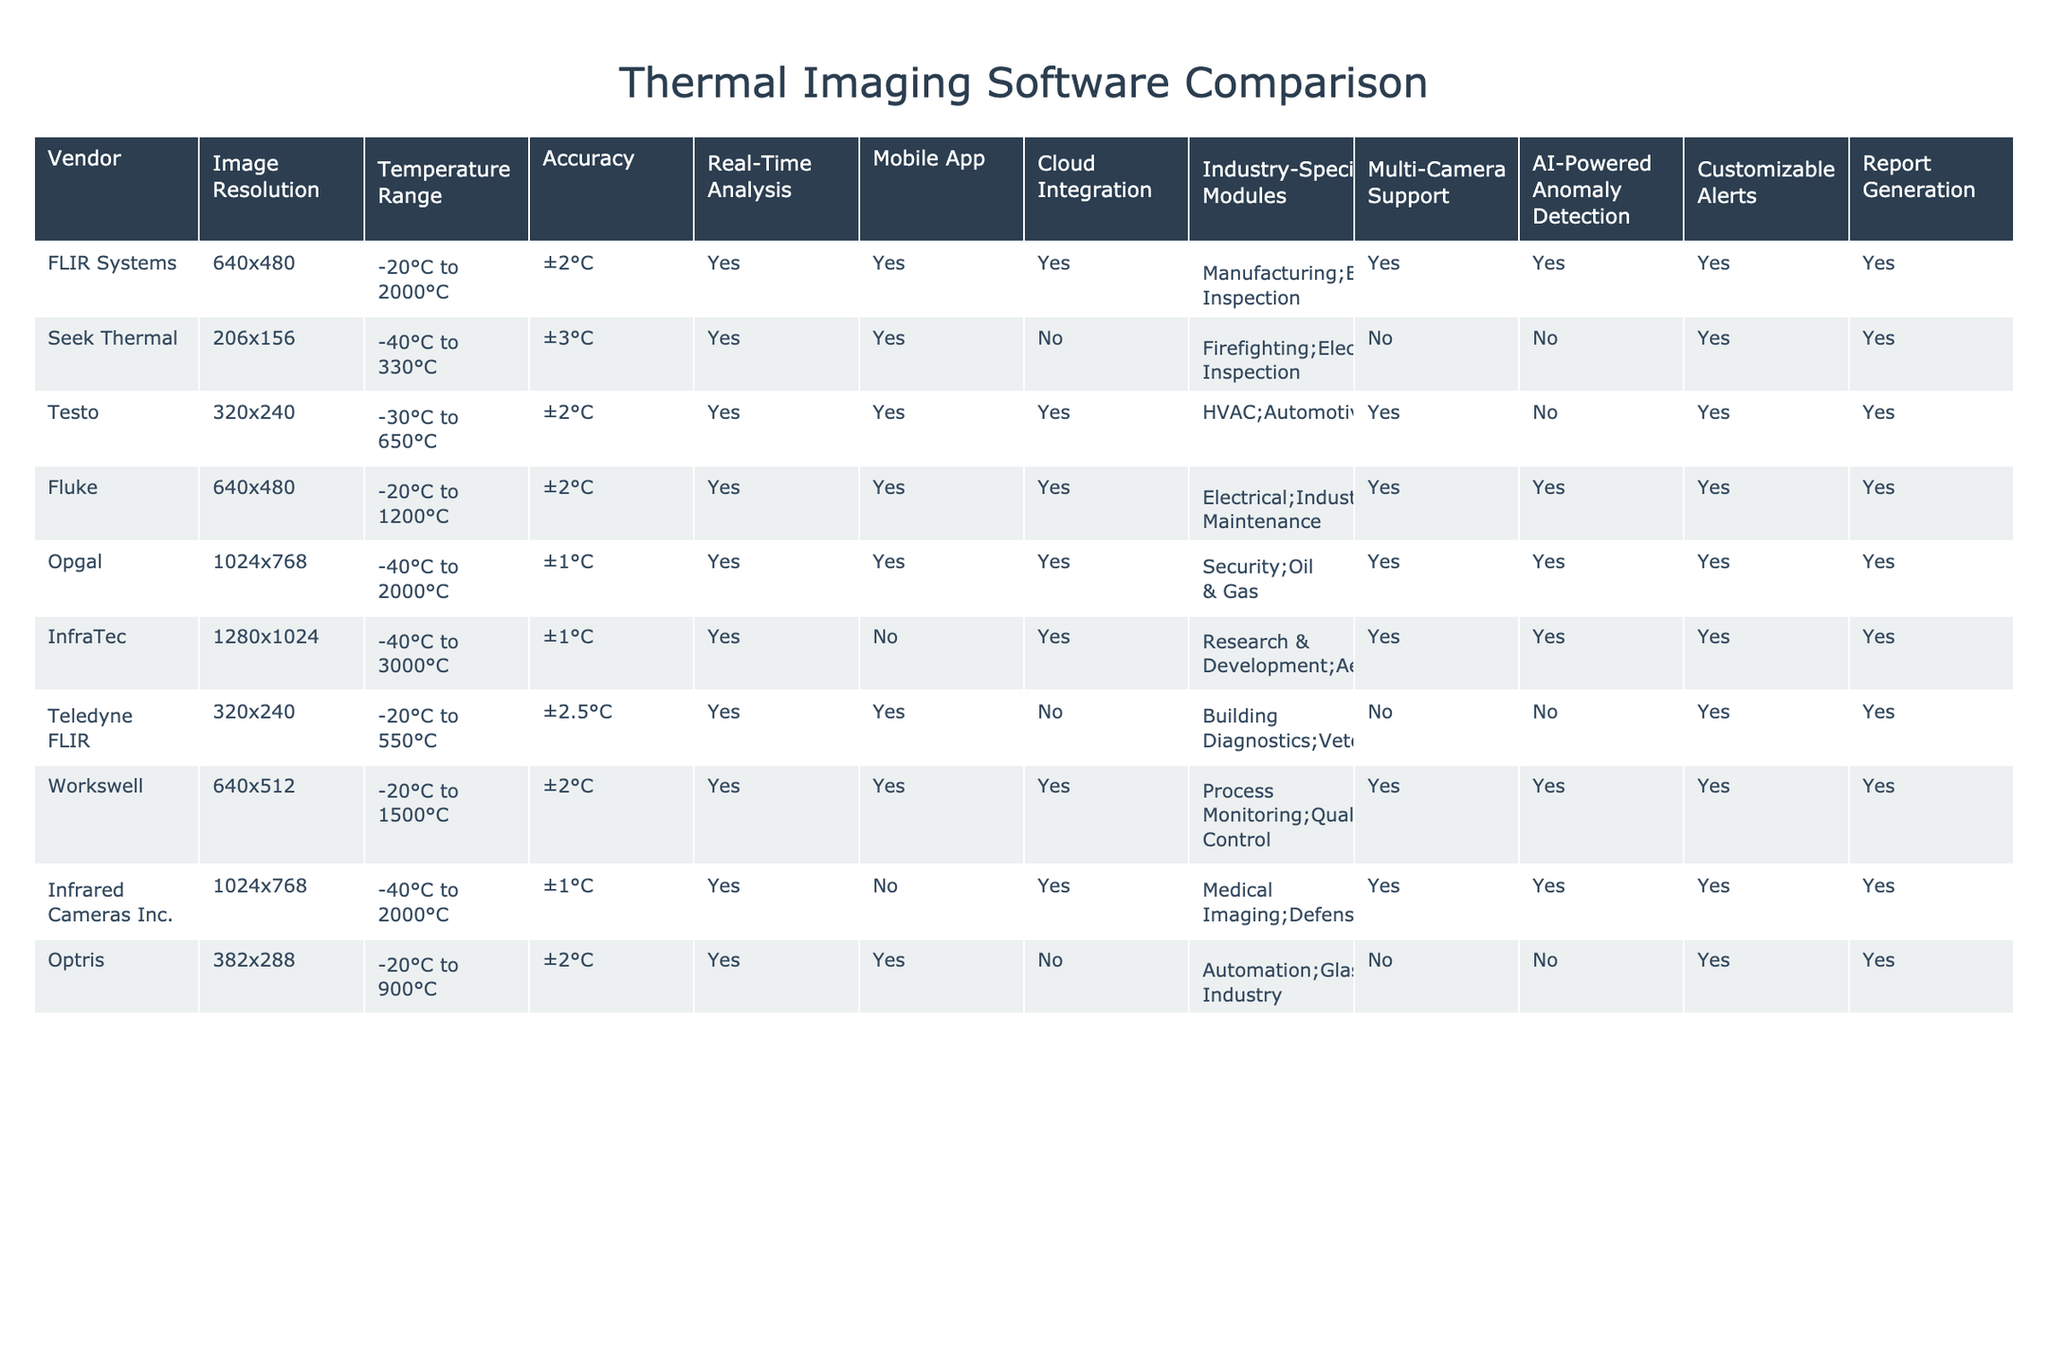What is the image resolution of InfraTec? The table lists InfraTec and states its image resolution. By looking at the corresponding row, we find that its image resolution is 1280x1024.
Answer: 1280x1024 Which vendor has the smallest temperature range? To determine which vendor has the smallest temperature range, we need to look at the temperature ranges of all vendors in the table. The smallest range is provided by Seek Thermal, which operates in the range of -40°C to 330°C.
Answer: -40°C to 330°C How many vendors support AI-powered anomaly detection? Counting the 'Yes' responses in the AI-Powered Anomaly Detection column, we find that seven vendors support this feature: FLIR Systems, Opgal, InfraTec, Workswell, Infrared Cameras Inc., Fluke, and Testo.
Answer: 7 What is the average accuracy of all vendors? The accuracy values of the vendors are: ±2°C (FLIR), ±3°C (Seek), ±2°C (Testo), ±2°C (Fluke), ±1°C (Opgal), ±1°C (InfraTec), ±2.5°C (Teledyne FLIR), ±2°C (Workswell), ±1°C (Infrared Cameras), and ±2°C (Optris). Converting them to numerical form, we compute the average: (2 + 3 + 2 + 2 + 1 + 1 + 2.5 + 2 + 1 + 2) / 10 = 1.85.
Answer: 1.85 Does Seek Thermal have cloud integration? Checking the cloud integration column for Seek Thermal shows a 'No'. Therefore, it does not have cloud integration.
Answer: No Which vendor provides the highest temperature range? To find out which vendor offers the highest temperature range, we analyze the temperature ranges provided. InfraTec supports the highest range, from -40°C to 3000°C.
Answer: -40°C to 3000°C How many vendors offer a mobile app? By reviewing the Mobile App column, we see that seven vendors, FLIR Systems, Seek Thermal, Testo, Fluke, Opgal, Teledyne FLIR, and Workswell, offer a mobile app.
Answer: 7 Is cloud integration available for Optris? Reviewing the cloud integration information, we see that the entry for Optris indicates 'No'; therefore, cloud integration is not available for Optris.
Answer: No 